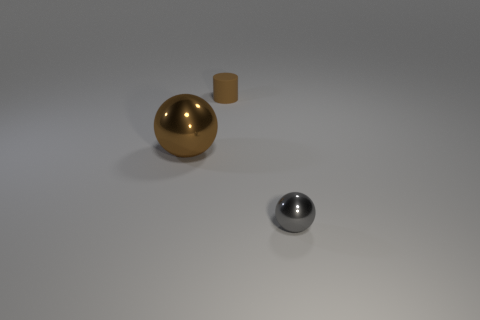Add 2 brown shiny balls. How many objects exist? 5 Add 1 large metal balls. How many large metal balls are left? 2 Add 1 gray things. How many gray things exist? 2 Subtract 0 purple cylinders. How many objects are left? 3 Subtract all cylinders. How many objects are left? 2 Subtract all tiny spheres. Subtract all brown metal objects. How many objects are left? 1 